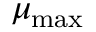<formula> <loc_0><loc_0><loc_500><loc_500>\mu _ { \max }</formula> 